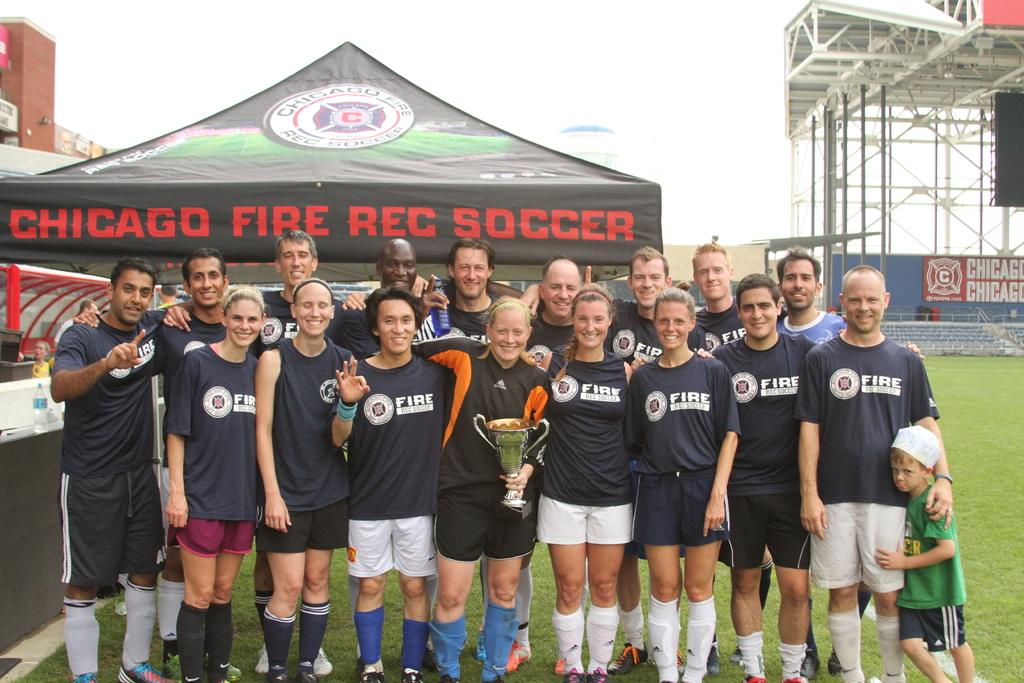What city is this team from?
Make the answer very short. Chicago. What is the name of this team?
Provide a short and direct response. Fire rec. 